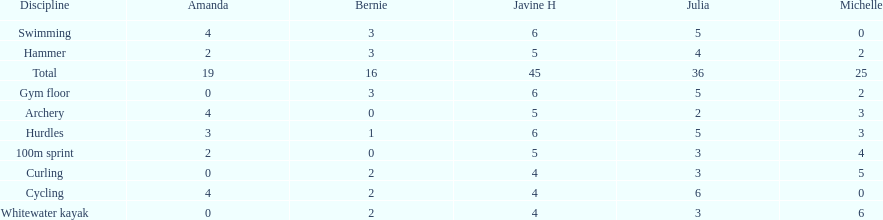What is the last discipline listed on this chart? 100m sprint. 